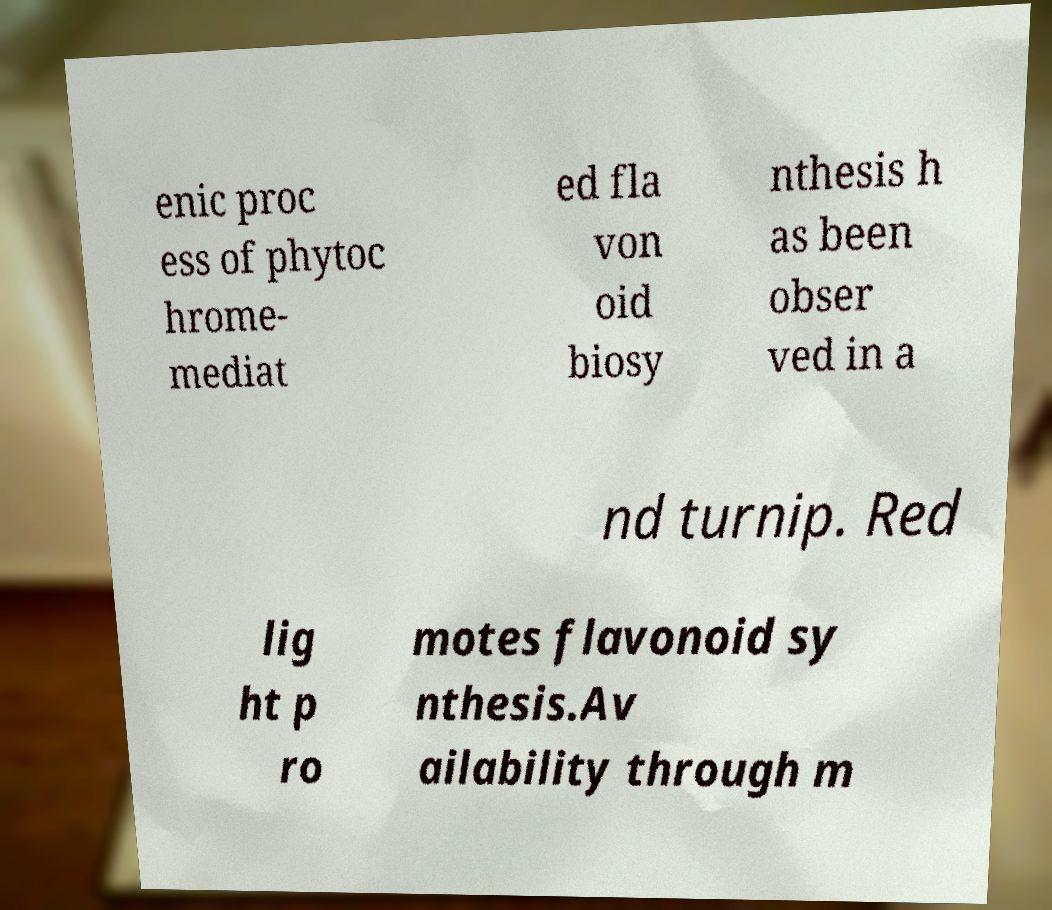I need the written content from this picture converted into text. Can you do that? enic proc ess of phytoc hrome- mediat ed fla von oid biosy nthesis h as been obser ved in a nd turnip. Red lig ht p ro motes flavonoid sy nthesis.Av ailability through m 